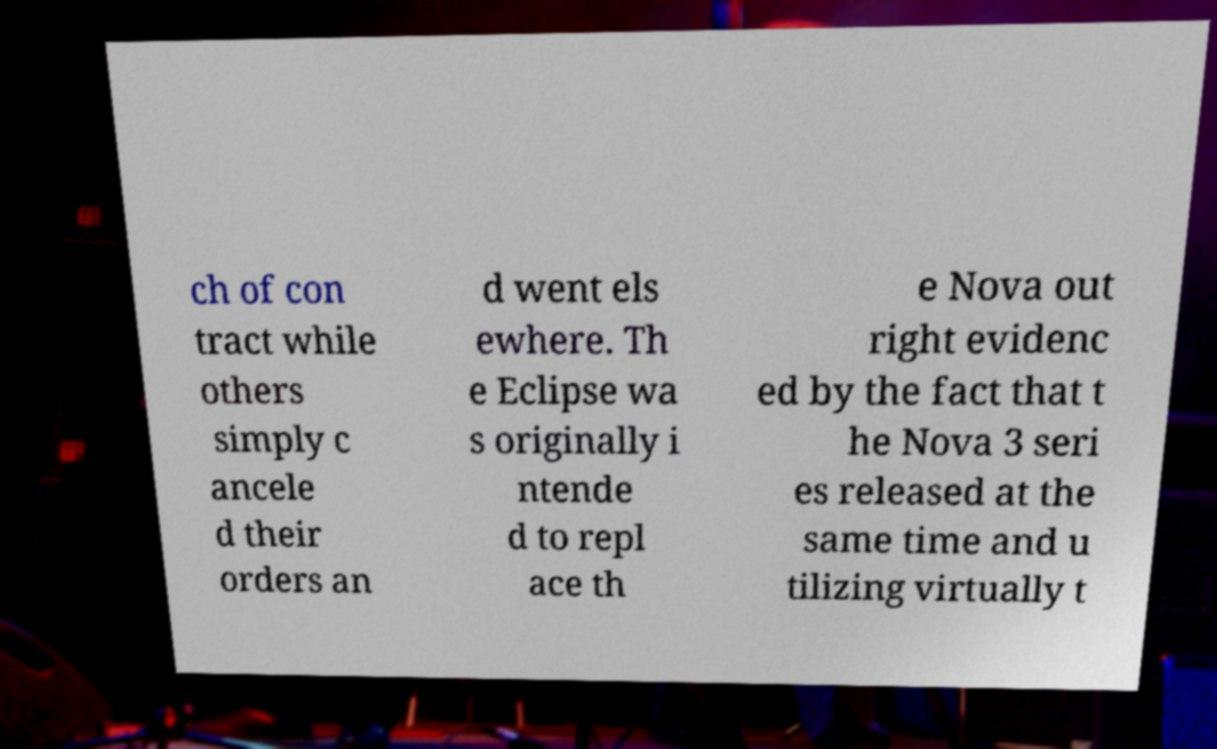Please read and relay the text visible in this image. What does it say? ch of con tract while others simply c ancele d their orders an d went els ewhere. Th e Eclipse wa s originally i ntende d to repl ace th e Nova out right evidenc ed by the fact that t he Nova 3 seri es released at the same time and u tilizing virtually t 